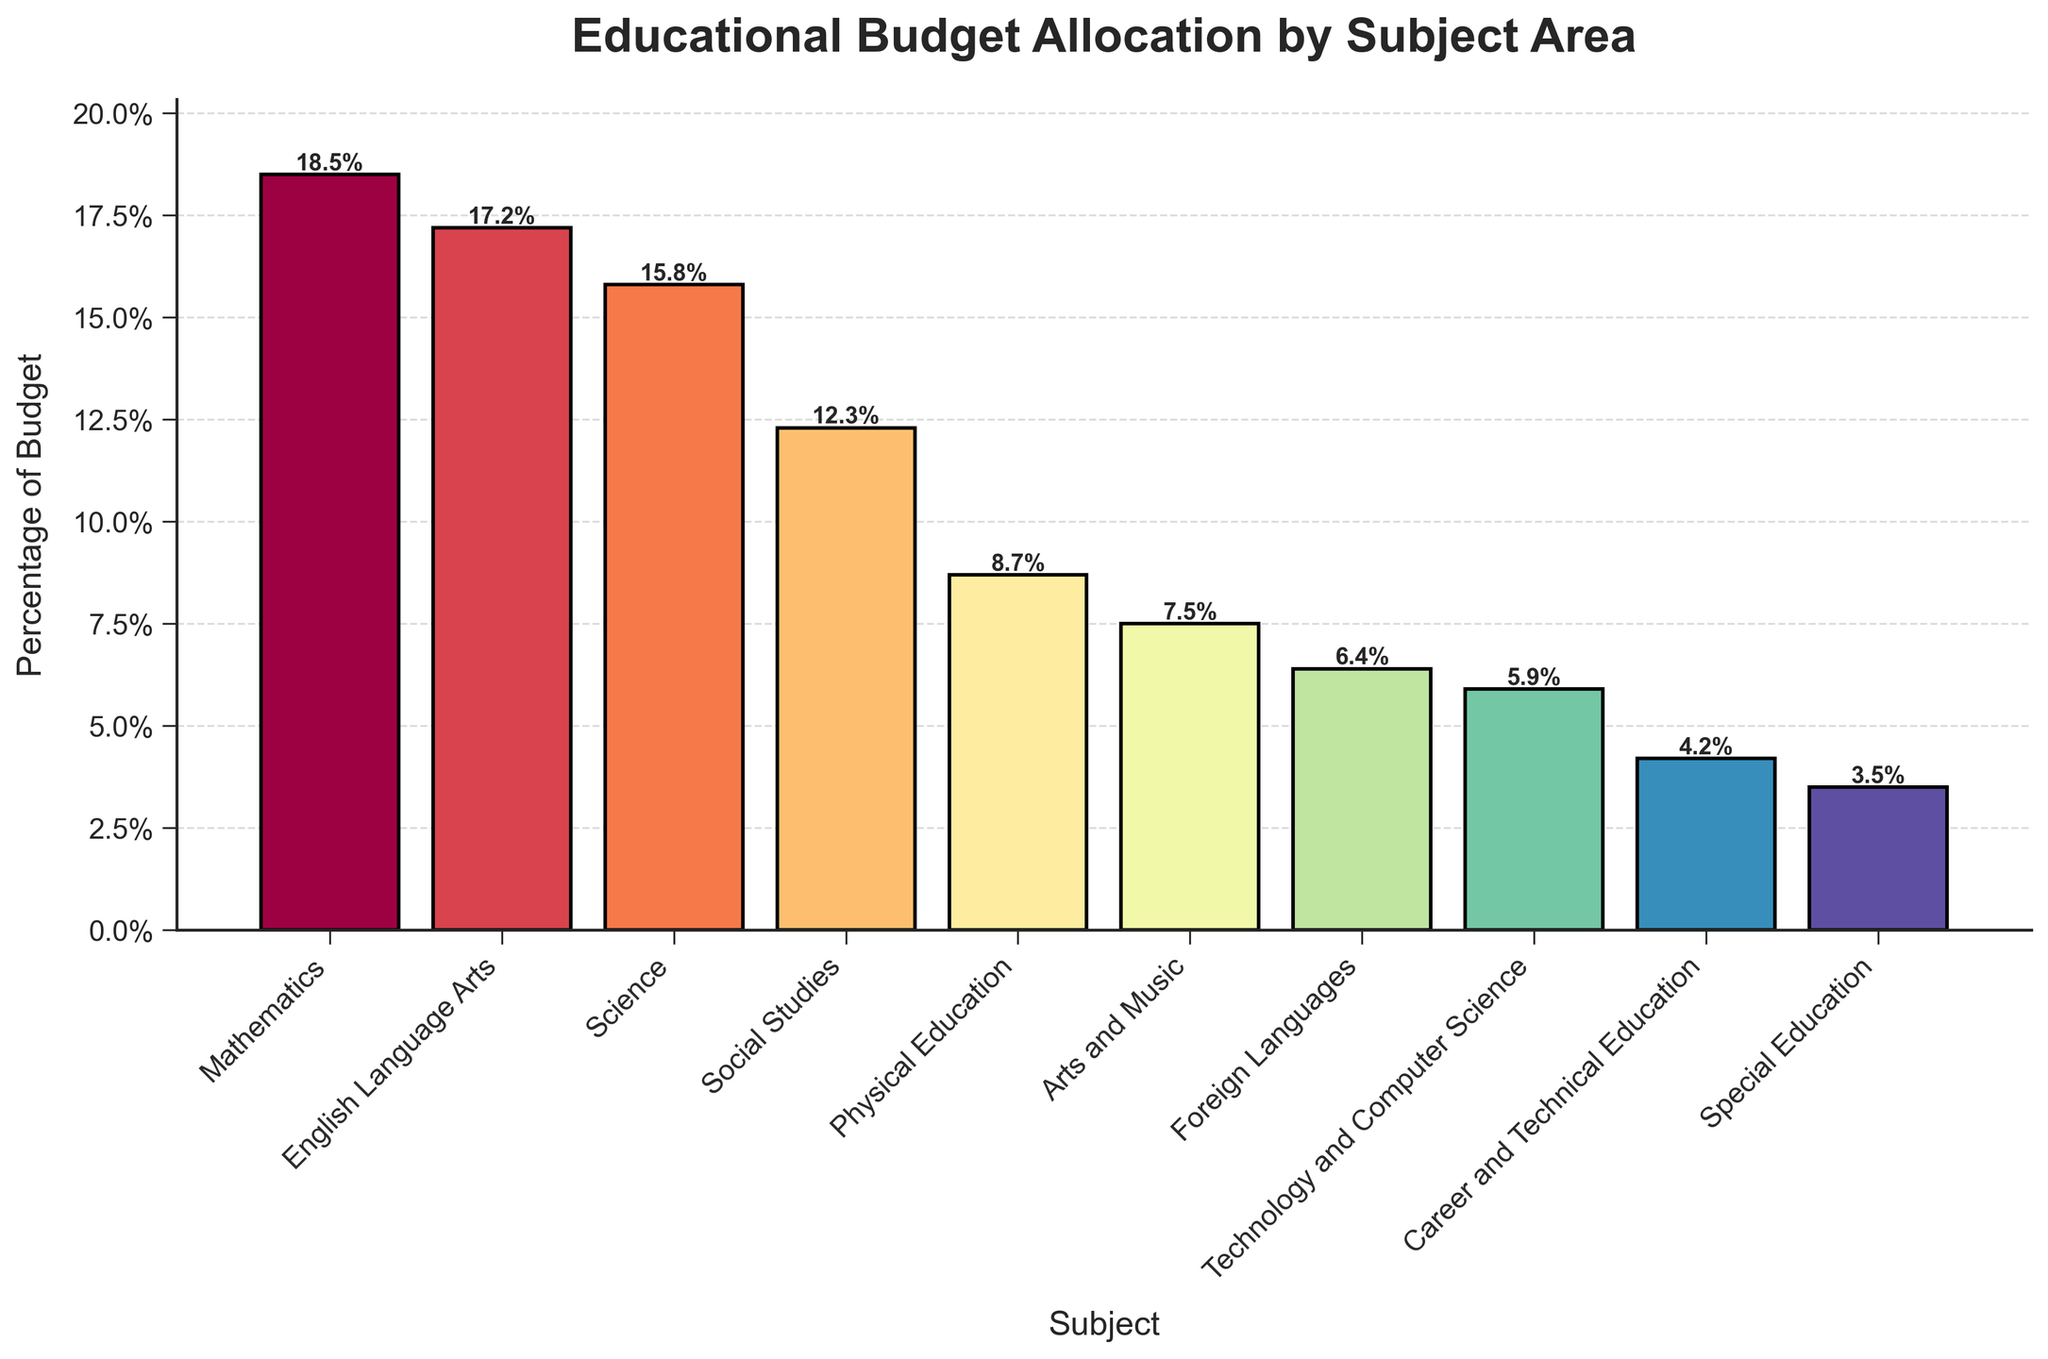Which subject area receives the highest percentage of the educational budget? The height of the bars represents the percentage of the budget. The tallest bar corresponds to Mathematics with 18.5%.
Answer: Mathematics Which subject area receives the lowest percentage of the educational budget? The shortest bar indicates the lowest percentage. Special Education has the shortest bar with 3.5%.
Answer: Special Education How much more budget is allocated to Mathematics compared to Arts and Music? The percentage for Mathematics is 18.5% and for Arts and Music is 7.5%. The difference is calculated as 18.5% - 7.5% = 11%.
Answer: 11% What is the total budget percentage allocated to English Language Arts, Science, and Social Studies together? Add the percentages for English Language Arts (17.2%), Science (15.8%), and Social Studies (12.3%). The total is 17.2% + 15.8% + 12.3% = 45.3%.
Answer: 45.3% Which subject areas have a budget allocation of less than 10%? Identify the bars with a budget allocation lower than 10%, which include Physical Education (8.7%), Arts and Music (7.5%), Foreign Languages (6.4%), Technology and Computer Science (5.9%), Career and Technical Education (4.2%), and Special Education (3.5%).
Answer: Physical Education, Arts and Music, Foreign Languages, Technology and Computer Science, Career and Technical Education, Special Education What is the combined budget percentage for Physical Education, Arts and Music, and Foreign Languages? Add the percentages for Physical Education (8.7%), Arts and Music (7.5%), and Foreign Languages (6.4%). The combined total is 8.7% + 7.5% + 6.4% = 22.6%.
Answer: 22.6% Which has a higher budget allocation: Technology and Computer Science or Foreign Languages? Compare the heights of the bars for Technology and Computer Science (5.9%) and Foreign Languages (6.4%). Foreign Languages have a higher allocation.
Answer: Foreign Languages Are there any subjects with equal budget allocations? Scan the bars for subjects with equal heights. None of the bars show equal budget allocations.
Answer: No What is the percentage difference between the highest and lowest budget allocations? The highest allocation is for Mathematics (18.5%) and the lowest for Special Education (3.5%). The difference is 18.5% - 3.5% = 15%.
Answer: 15% What is the average budget allocation for all subject areas? Sum all the percentages and divide by the number of subjects. Total sum is (18.5 + 17.2 + 15.8 + 12.3 + 8.7 + 7.5 + 6.4 + 5.9 + 4.2 + 3.5) = 100%. Since there are 10 subjects, the average is 100% / 10 = 10%.
Answer: 10% 